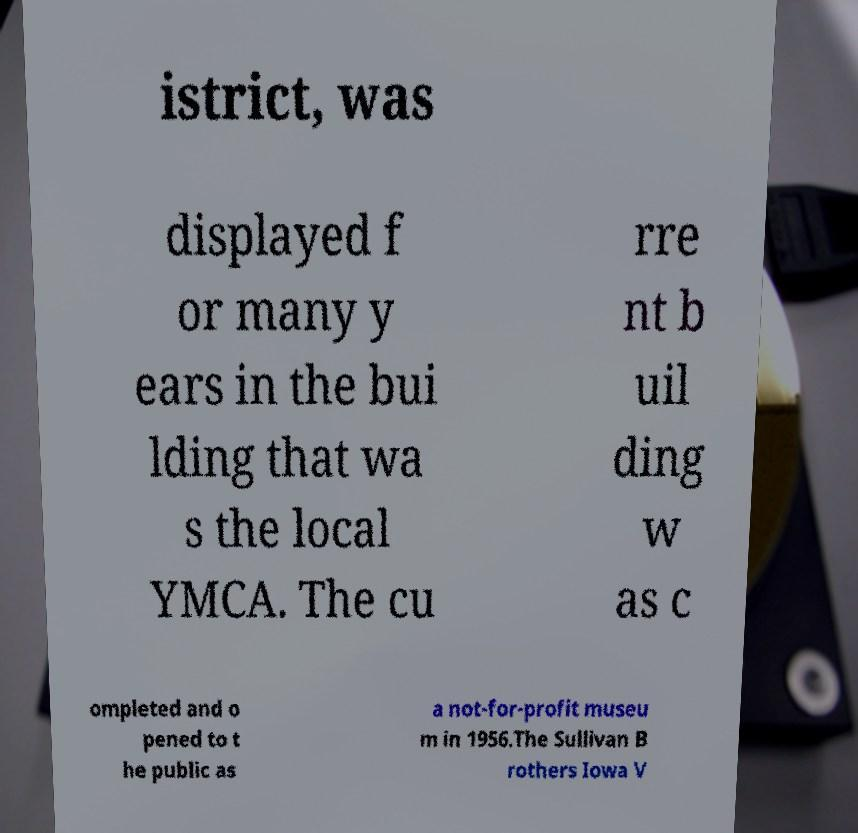Please identify and transcribe the text found in this image. istrict, was displayed f or many y ears in the bui lding that wa s the local YMCA. The cu rre nt b uil ding w as c ompleted and o pened to t he public as a not-for-profit museu m in 1956.The Sullivan B rothers Iowa V 